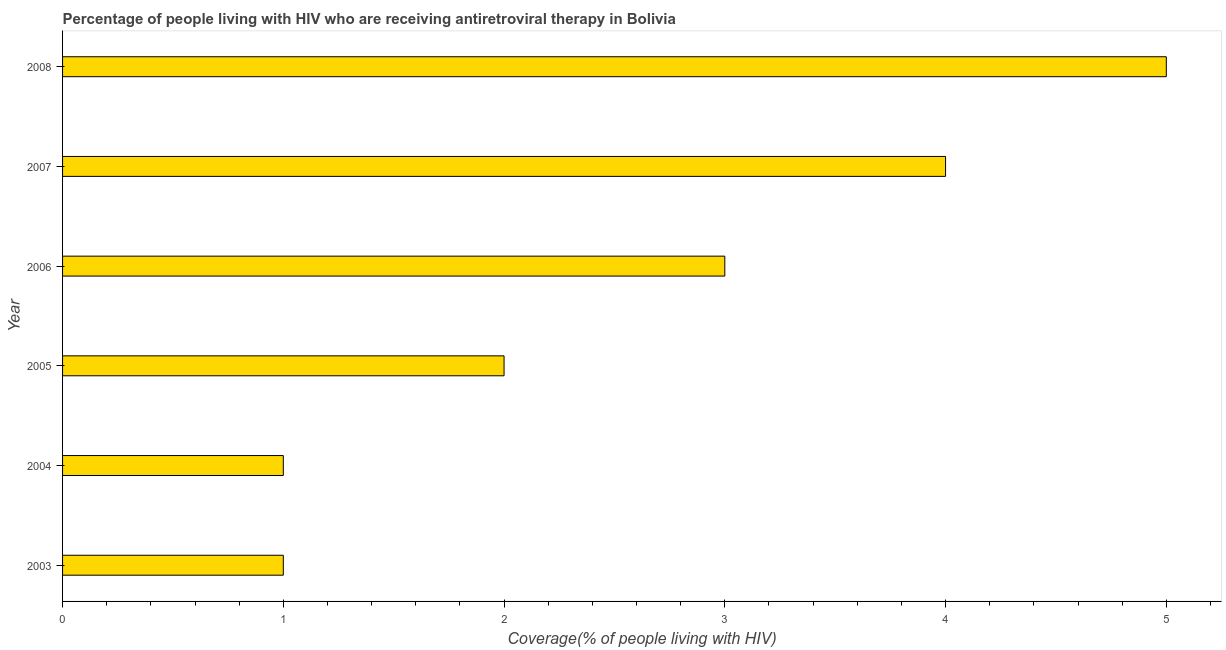Does the graph contain grids?
Make the answer very short. No. What is the title of the graph?
Your answer should be very brief. Percentage of people living with HIV who are receiving antiretroviral therapy in Bolivia. What is the label or title of the X-axis?
Provide a short and direct response. Coverage(% of people living with HIV). What is the antiretroviral therapy coverage in 2004?
Provide a short and direct response. 1. In which year was the antiretroviral therapy coverage minimum?
Make the answer very short. 2003. What is the median antiretroviral therapy coverage?
Offer a very short reply. 2.5. Is the difference between the antiretroviral therapy coverage in 2003 and 2004 greater than the difference between any two years?
Provide a succinct answer. No. In how many years, is the antiretroviral therapy coverage greater than the average antiretroviral therapy coverage taken over all years?
Offer a very short reply. 3. Are all the bars in the graph horizontal?
Make the answer very short. Yes. How many years are there in the graph?
Provide a succinct answer. 6. What is the Coverage(% of people living with HIV) in 2003?
Provide a short and direct response. 1. What is the Coverage(% of people living with HIV) of 2005?
Keep it short and to the point. 2. What is the Coverage(% of people living with HIV) of 2007?
Your answer should be very brief. 4. What is the Coverage(% of people living with HIV) in 2008?
Your answer should be very brief. 5. What is the difference between the Coverage(% of people living with HIV) in 2003 and 2007?
Provide a succinct answer. -3. What is the difference between the Coverage(% of people living with HIV) in 2004 and 2007?
Your answer should be very brief. -3. What is the difference between the Coverage(% of people living with HIV) in 2004 and 2008?
Your response must be concise. -4. What is the difference between the Coverage(% of people living with HIV) in 2005 and 2006?
Keep it short and to the point. -1. What is the difference between the Coverage(% of people living with HIV) in 2005 and 2007?
Offer a very short reply. -2. What is the difference between the Coverage(% of people living with HIV) in 2005 and 2008?
Ensure brevity in your answer.  -3. What is the difference between the Coverage(% of people living with HIV) in 2006 and 2007?
Ensure brevity in your answer.  -1. What is the difference between the Coverage(% of people living with HIV) in 2007 and 2008?
Provide a short and direct response. -1. What is the ratio of the Coverage(% of people living with HIV) in 2003 to that in 2005?
Ensure brevity in your answer.  0.5. What is the ratio of the Coverage(% of people living with HIV) in 2003 to that in 2006?
Offer a terse response. 0.33. What is the ratio of the Coverage(% of people living with HIV) in 2003 to that in 2007?
Your answer should be compact. 0.25. What is the ratio of the Coverage(% of people living with HIV) in 2004 to that in 2005?
Provide a succinct answer. 0.5. What is the ratio of the Coverage(% of people living with HIV) in 2004 to that in 2006?
Keep it short and to the point. 0.33. What is the ratio of the Coverage(% of people living with HIV) in 2004 to that in 2008?
Offer a terse response. 0.2. What is the ratio of the Coverage(% of people living with HIV) in 2005 to that in 2006?
Give a very brief answer. 0.67. What is the ratio of the Coverage(% of people living with HIV) in 2005 to that in 2007?
Provide a succinct answer. 0.5. What is the ratio of the Coverage(% of people living with HIV) in 2005 to that in 2008?
Provide a short and direct response. 0.4. What is the ratio of the Coverage(% of people living with HIV) in 2006 to that in 2007?
Provide a short and direct response. 0.75. What is the ratio of the Coverage(% of people living with HIV) in 2006 to that in 2008?
Offer a terse response. 0.6. 